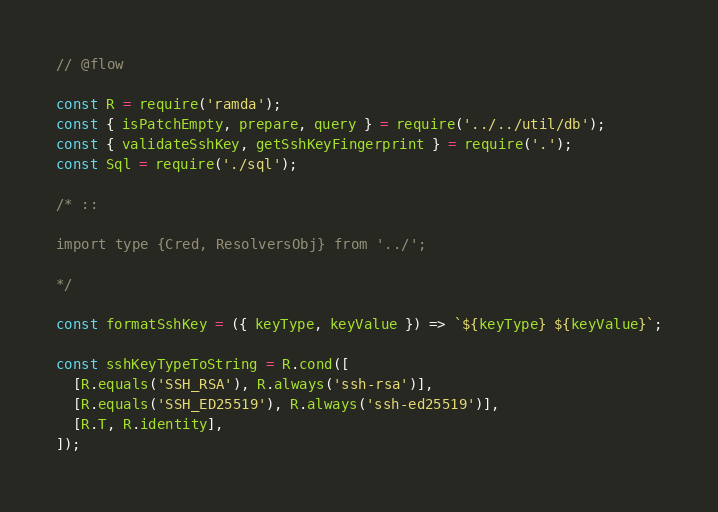<code> <loc_0><loc_0><loc_500><loc_500><_JavaScript_>// @flow

const R = require('ramda');
const { isPatchEmpty, prepare, query } = require('../../util/db');
const { validateSshKey, getSshKeyFingerprint } = require('.');
const Sql = require('./sql');

/* ::

import type {Cred, ResolversObj} from '../';

*/

const formatSshKey = ({ keyType, keyValue }) => `${keyType} ${keyValue}`;

const sshKeyTypeToString = R.cond([
  [R.equals('SSH_RSA'), R.always('ssh-rsa')],
  [R.equals('SSH_ED25519'), R.always('ssh-ed25519')],
  [R.T, R.identity],
]);
</code> 